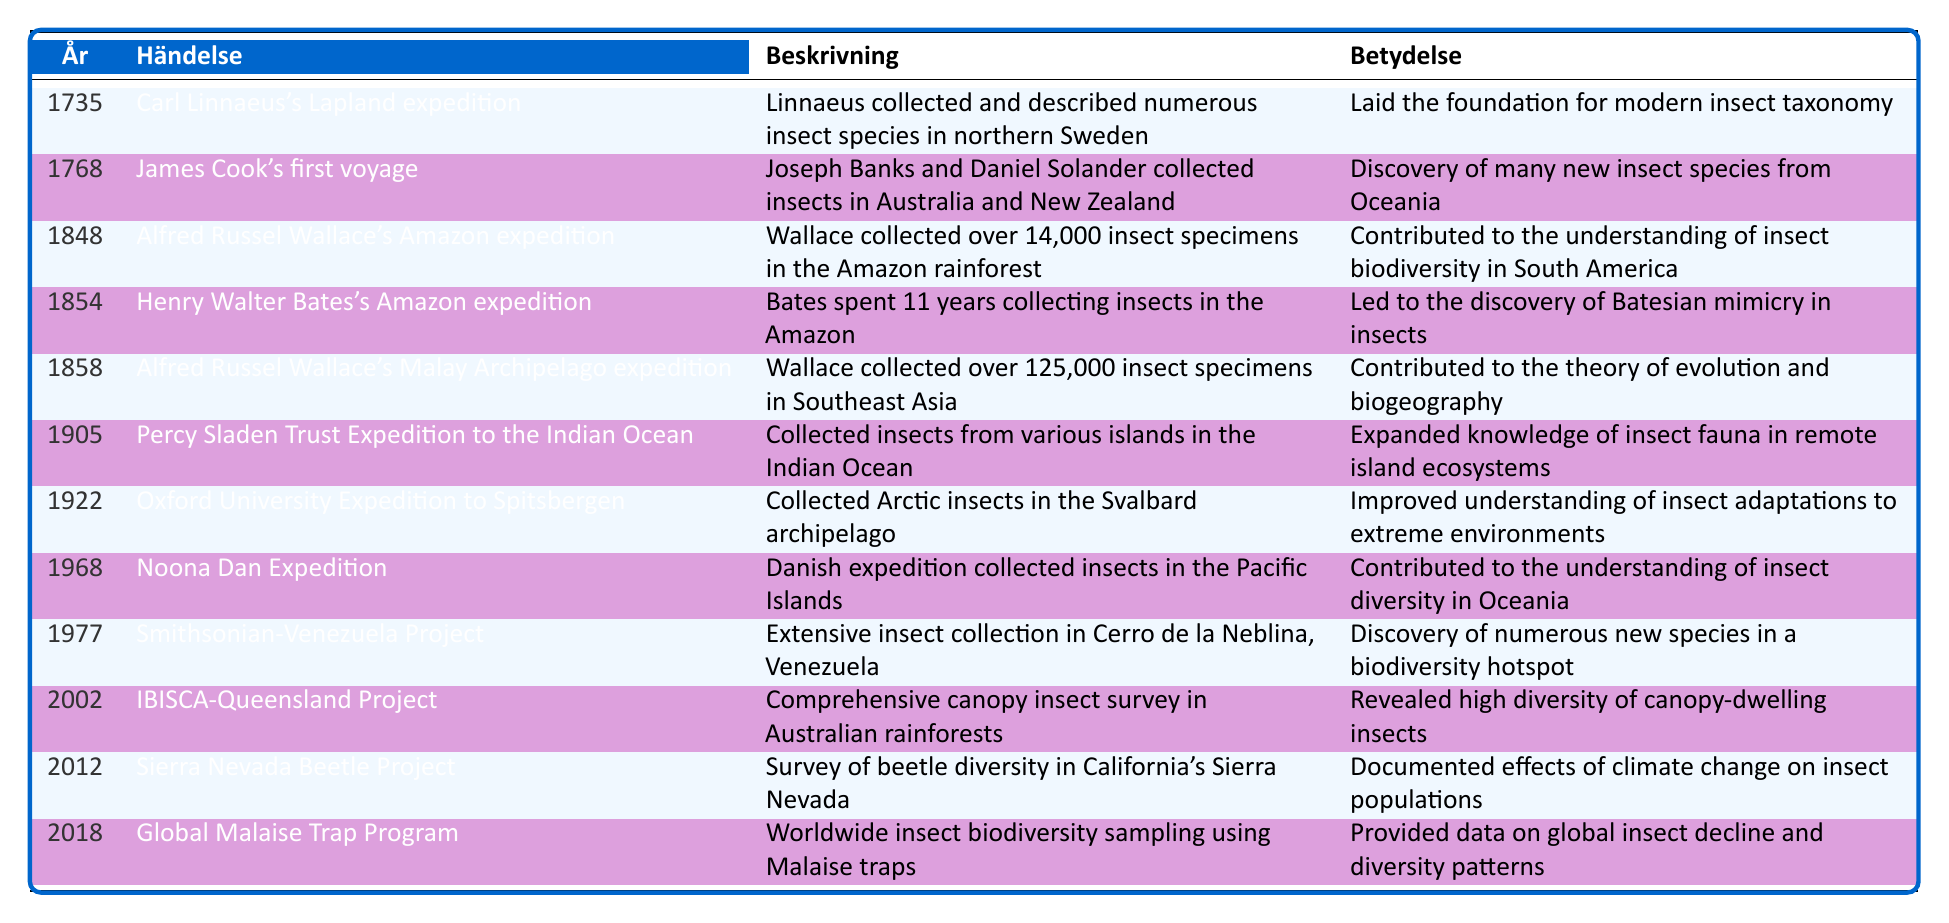What year did Carl Linnaeus's Lapland expedition take place? The year is explicitly mentioned in the table next to the event. It shows "1735" under the year column corresponding to Carl Linnaeus's Lapland expedition.
Answer: 1735 Which expedition collected the most insect specimens, and how many were collected? According to the table, Alfred Russel Wallace's Malay Archipelago expedition collected over 125,000 insect specimens, which is the highest number listed.
Answer: Over 125,000 Was the Noona Dan Expedition focused on collecting insects in the Indian Ocean? The table specifies that the Noona Dan Expedition was conducted in the Pacific Islands, not the Indian Ocean, making this statement false.
Answer: No How many years apart were Alfred Russel Wallace's Amazon expedition and Henry Walter Bates's Amazon expedition? Wallace's Amazon expedition occurred in 1848 and Bates's expedition in 1854. The difference in years is 1854 - 1848 = 6 years.
Answer: 6 years What notable contribution did Henry Walter Bates's Amazon expedition lead to? The significance of the expedition is stated in the table, indicating that it led to the discovery of Batesian mimicry in insects.
Answer: Discovery of Batesian mimicry How many expeditions occurred before the year 1900? By reviewing the years listed in the table, the expeditions that took place before 1900 are: Linnaeus's (1735), Cook's (1768), Wallace's Amazon (1848), Bates's (1854), Wallace's Malay Archipelago (1858), and Sladen Expedition (1905), totaling 5 expeditions.
Answer: 5 expeditions What was the significance of the Global Malaise Trap Program? The table states that it provided data on global insect decline and diversity patterns, indicating its importance in understanding insect biodiversity.
Answer: Provided data on global insect decline and diversity patterns Which expedition improved the understanding of insect adaptations to extreme environments? The table indicates that the Oxford University Expedition to Spitsbergen, in 1922, focused on Arctic insects, contributing to the understanding of adaptations to extreme environments.
Answer: Oxford University Expedition to Spitsbergen 